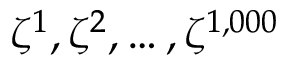Convert formula to latex. <formula><loc_0><loc_0><loc_500><loc_500>\zeta ^ { 1 } , \zeta ^ { 2 } , \dots , \zeta ^ { 1 , 0 0 0 }</formula> 